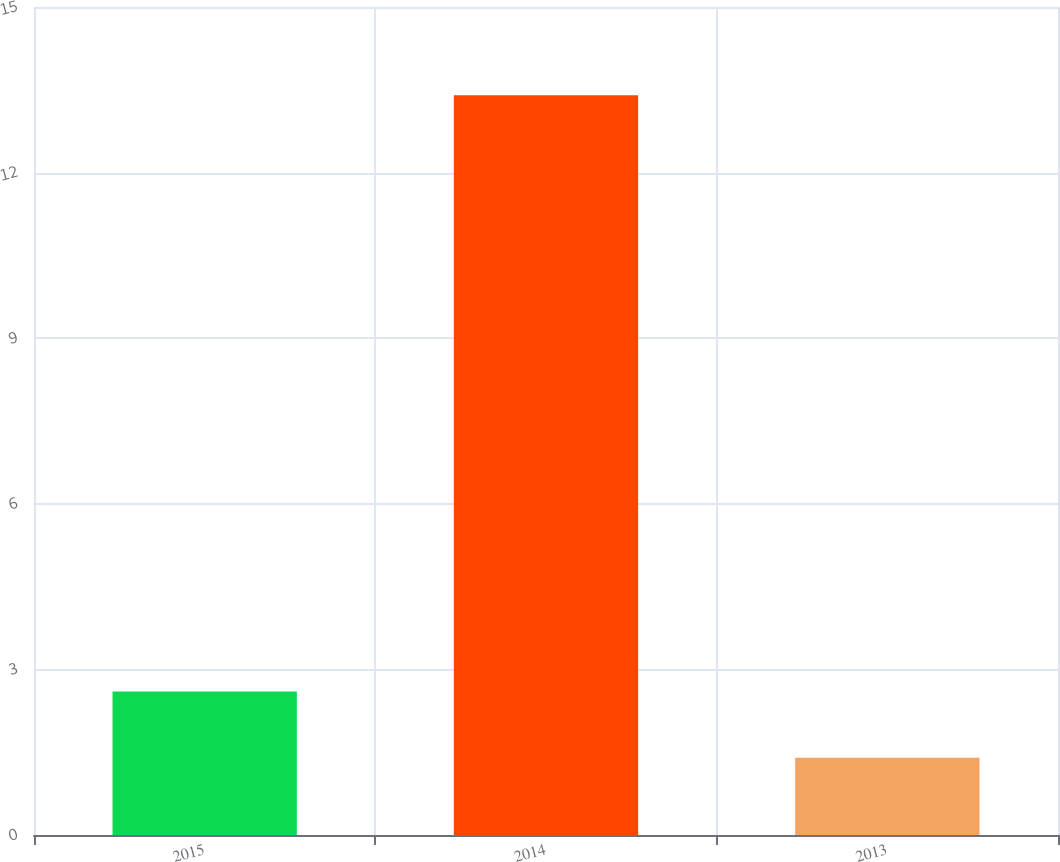Convert chart to OTSL. <chart><loc_0><loc_0><loc_500><loc_500><bar_chart><fcel>2015<fcel>2014<fcel>2013<nl><fcel>2.6<fcel>13.4<fcel>1.4<nl></chart> 